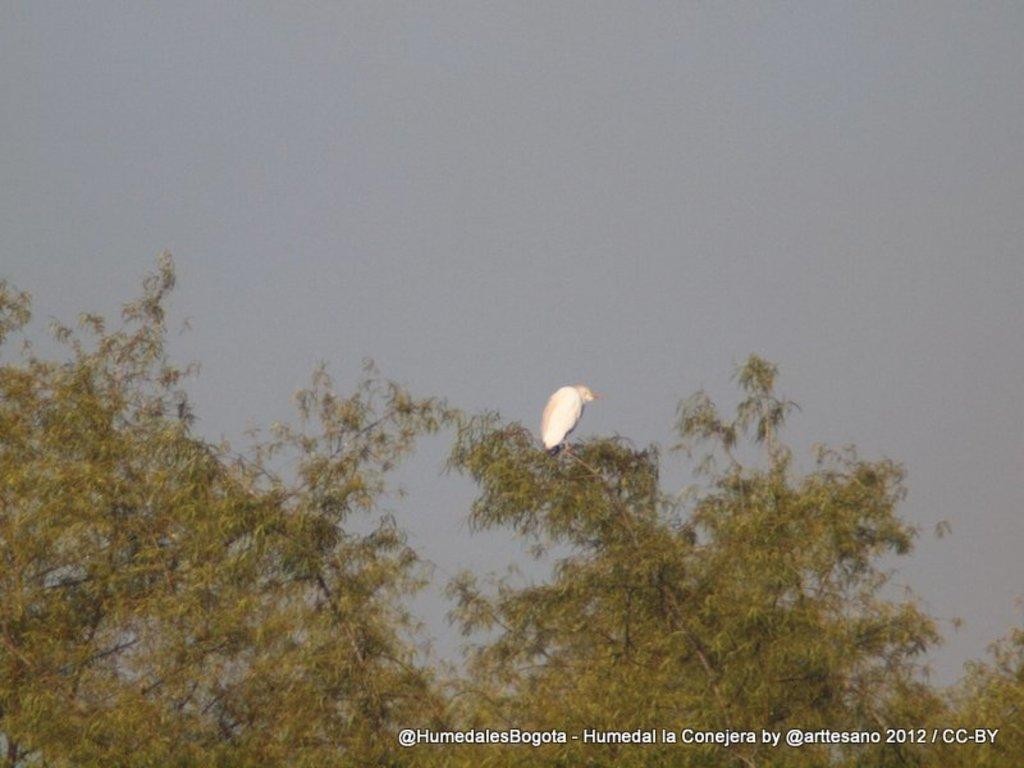In one or two sentences, can you explain what this image depicts? In this image there is one bird as we can see in middle of this image and there are some trees at bottom of this image and there is a sky at top of this image. 